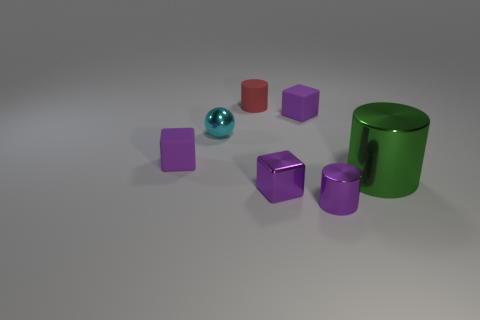How many purple cubes must be subtracted to get 1 purple cubes? 2 Add 3 small cylinders. How many objects exist? 10 Subtract all tiny rubber cubes. How many cubes are left? 1 Subtract 1 cylinders. How many cylinders are left? 2 Subtract all blue cylinders. Subtract all yellow blocks. How many cylinders are left? 3 Subtract 0 yellow spheres. How many objects are left? 7 Subtract all cylinders. How many objects are left? 4 Subtract all green metal objects. Subtract all small rubber things. How many objects are left? 3 Add 3 metal things. How many metal things are left? 7 Add 2 large gray metal spheres. How many large gray metal spheres exist? 2 